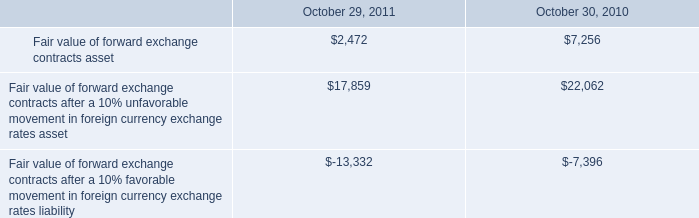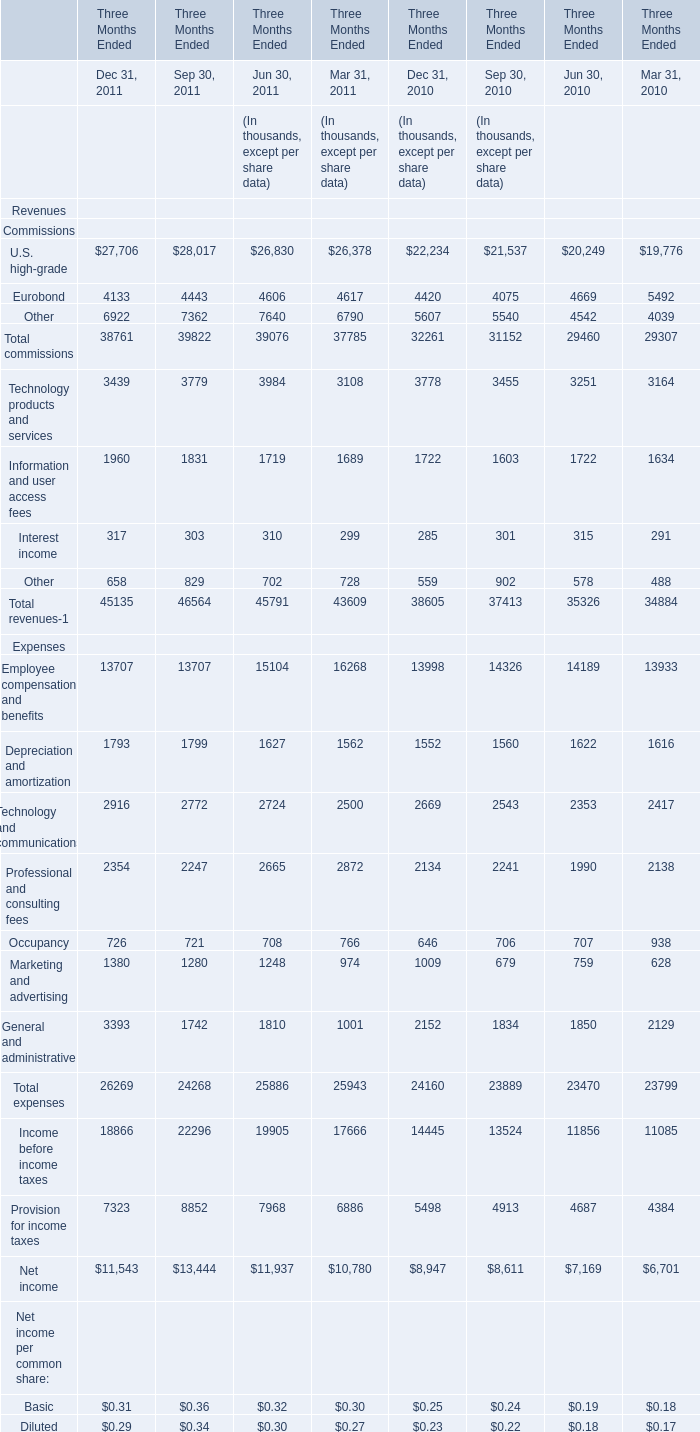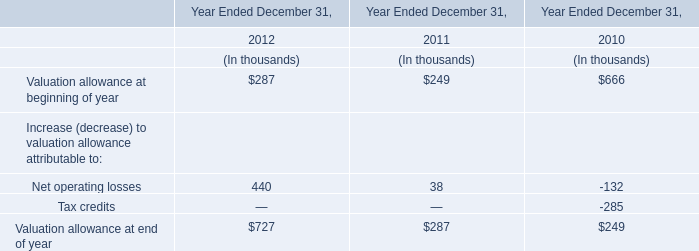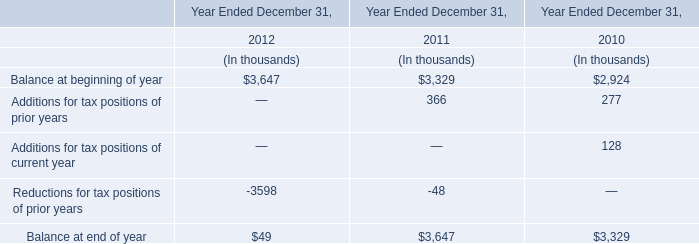In the year with the greatest proportion of Eurobond, what is the proportion of Eurobond of Commissions to the tatal? 
Computations: ((((4420 + 4075) + 4669) + 5492) / (((32261 + 31152) + 29460) + 29307))
Answer: 0.15269. 